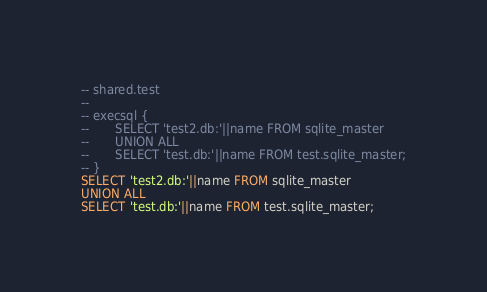Convert code to text. <code><loc_0><loc_0><loc_500><loc_500><_SQL_>-- shared.test
-- 
-- execsql {
--       SELECT 'test2.db:'||name FROM sqlite_master 
--       UNION ALL
--       SELECT 'test.db:'||name FROM test.sqlite_master;
-- }
SELECT 'test2.db:'||name FROM sqlite_master 
UNION ALL
SELECT 'test.db:'||name FROM test.sqlite_master;</code> 